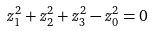Convert formula to latex. <formula><loc_0><loc_0><loc_500><loc_500>z _ { 1 } ^ { 2 } + z _ { 2 } ^ { 2 } + z _ { 3 } ^ { 2 } - z _ { 0 } ^ { 2 } = 0</formula> 